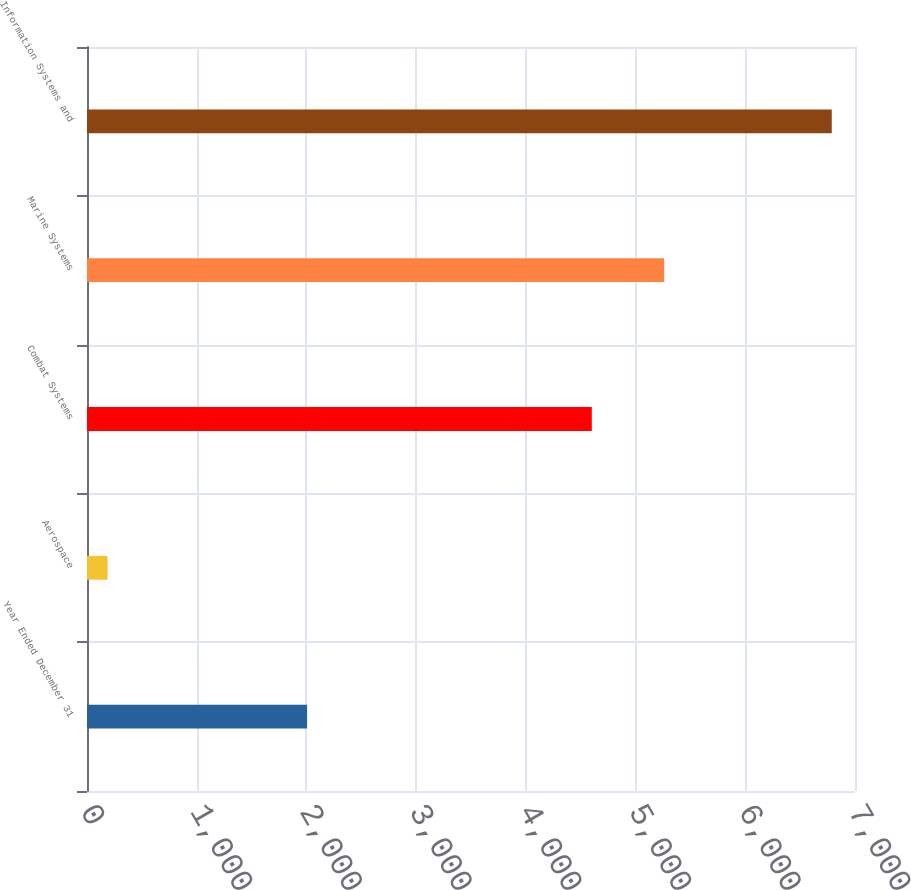Convert chart to OTSL. <chart><loc_0><loc_0><loc_500><loc_500><bar_chart><fcel>Year Ended December 31<fcel>Aerospace<fcel>Combat Systems<fcel>Marine Systems<fcel>Information Systems and<nl><fcel>2006<fcel>187<fcel>4601<fcel>5261.1<fcel>6788<nl></chart> 